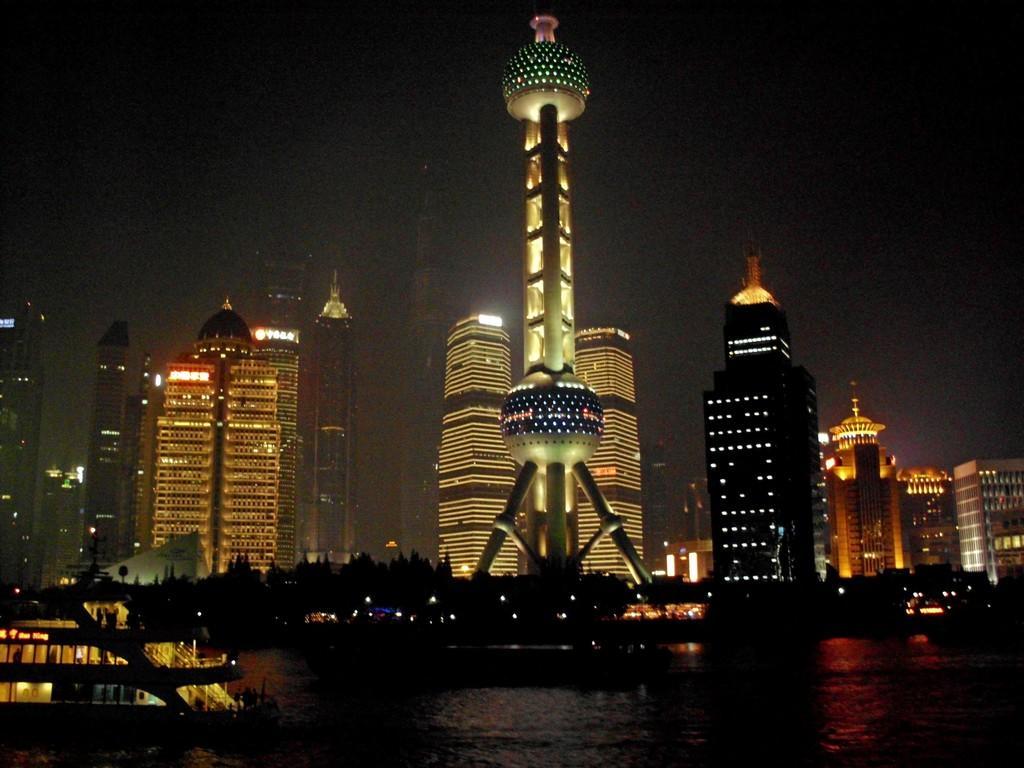How would you summarize this image in a sentence or two? In this picture I can see a boat on the water, there are trees, a tower and there are buildings. 